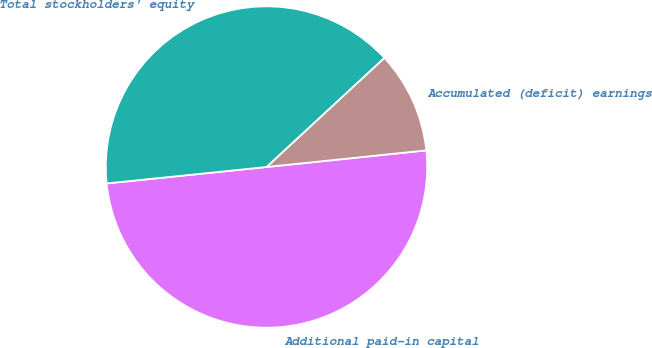Convert chart. <chart><loc_0><loc_0><loc_500><loc_500><pie_chart><fcel>Additional paid-in capital<fcel>Accumulated (deficit) earnings<fcel>Total stockholders' equity<nl><fcel>50.02%<fcel>10.24%<fcel>39.74%<nl></chart> 